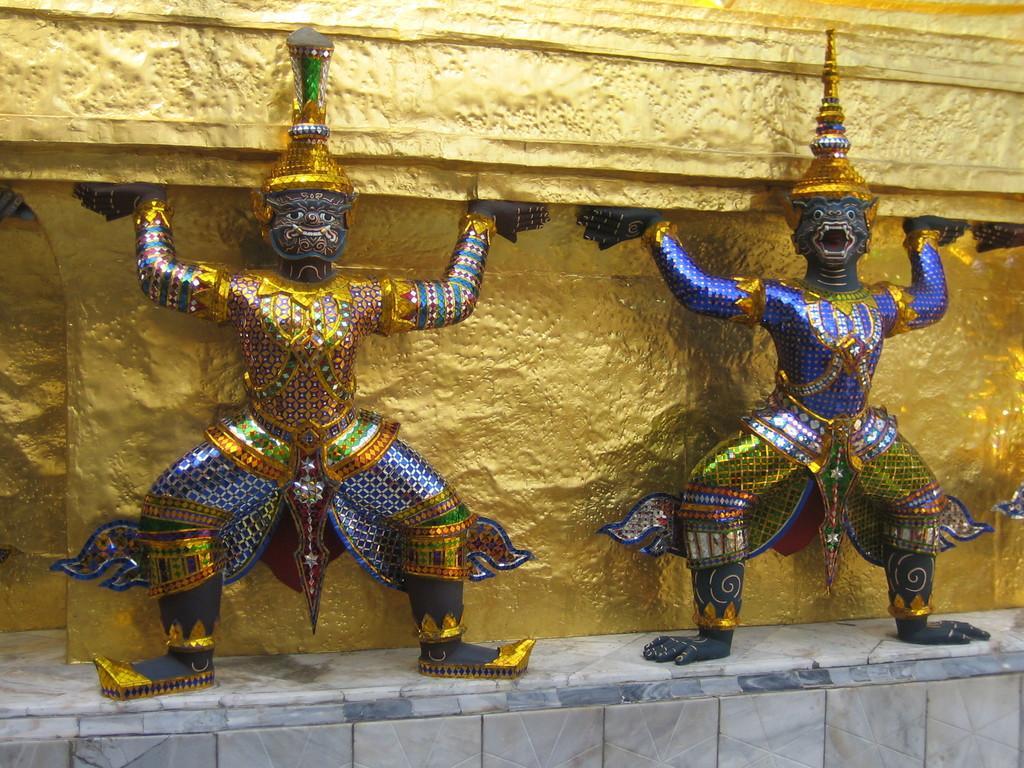Can you describe this image briefly? In this image, we can see sculptures in front of the wall. 